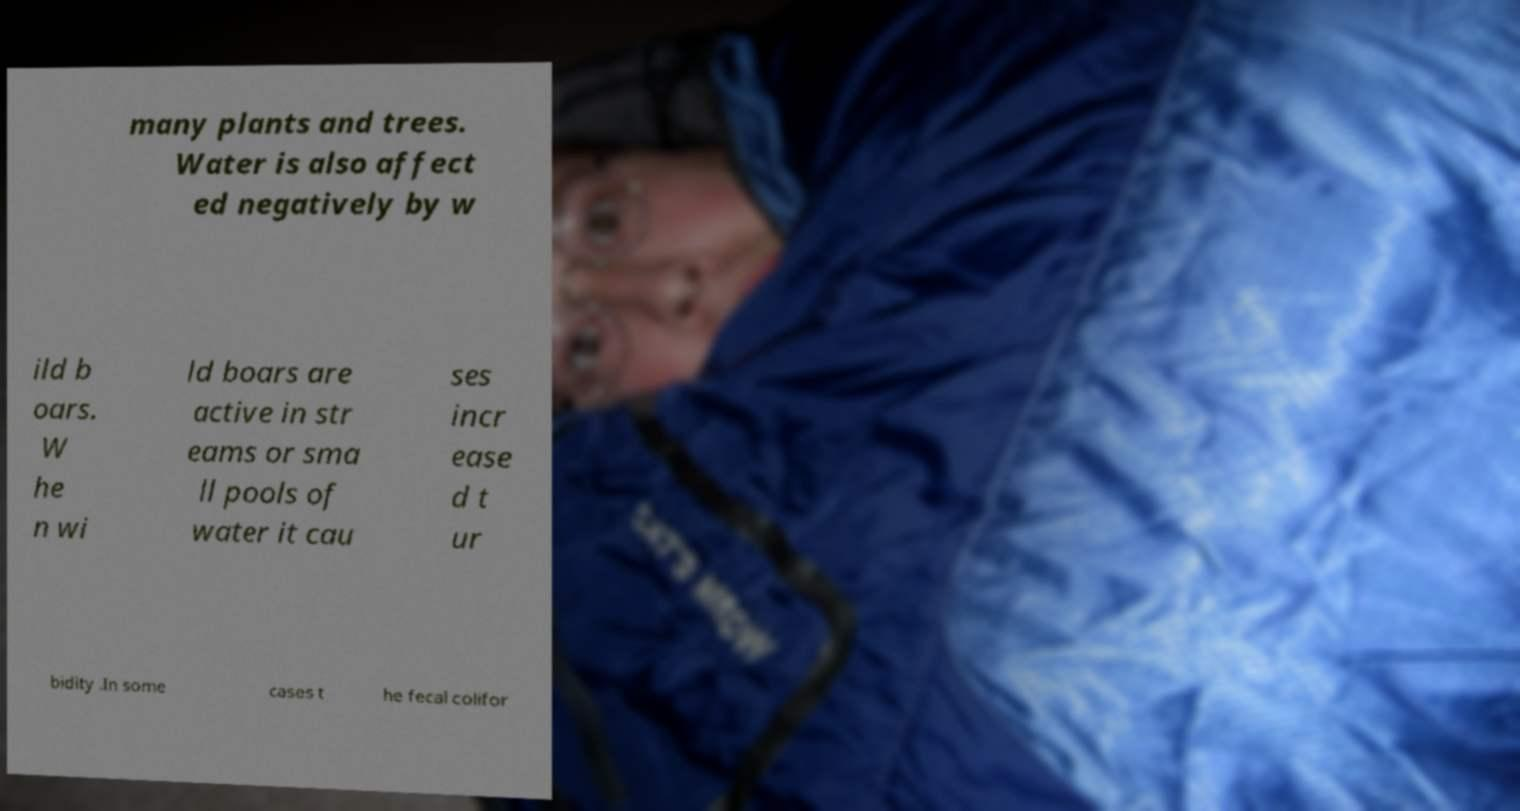Can you read and provide the text displayed in the image?This photo seems to have some interesting text. Can you extract and type it out for me? many plants and trees. Water is also affect ed negatively by w ild b oars. W he n wi ld boars are active in str eams or sma ll pools of water it cau ses incr ease d t ur bidity .In some cases t he fecal colifor 